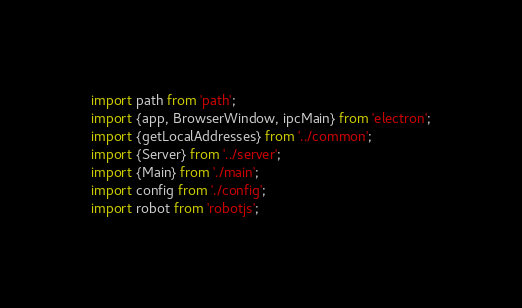Convert code to text. <code><loc_0><loc_0><loc_500><loc_500><_JavaScript_>import path from 'path';
import {app, BrowserWindow, ipcMain} from 'electron';
import {getLocalAddresses} from '../common';
import {Server} from '../server';
import {Main} from './main';
import config from './config';
import robot from 'robotjs';
</code> 